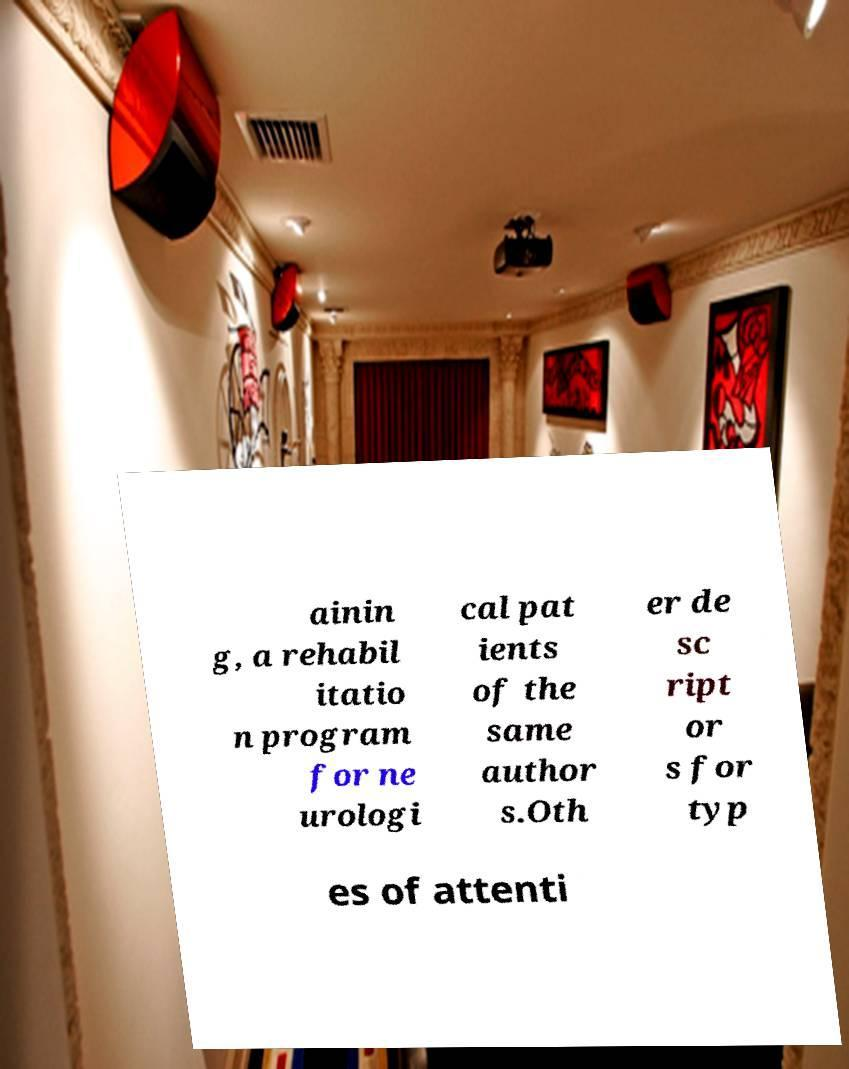Please identify and transcribe the text found in this image. ainin g, a rehabil itatio n program for ne urologi cal pat ients of the same author s.Oth er de sc ript or s for typ es of attenti 